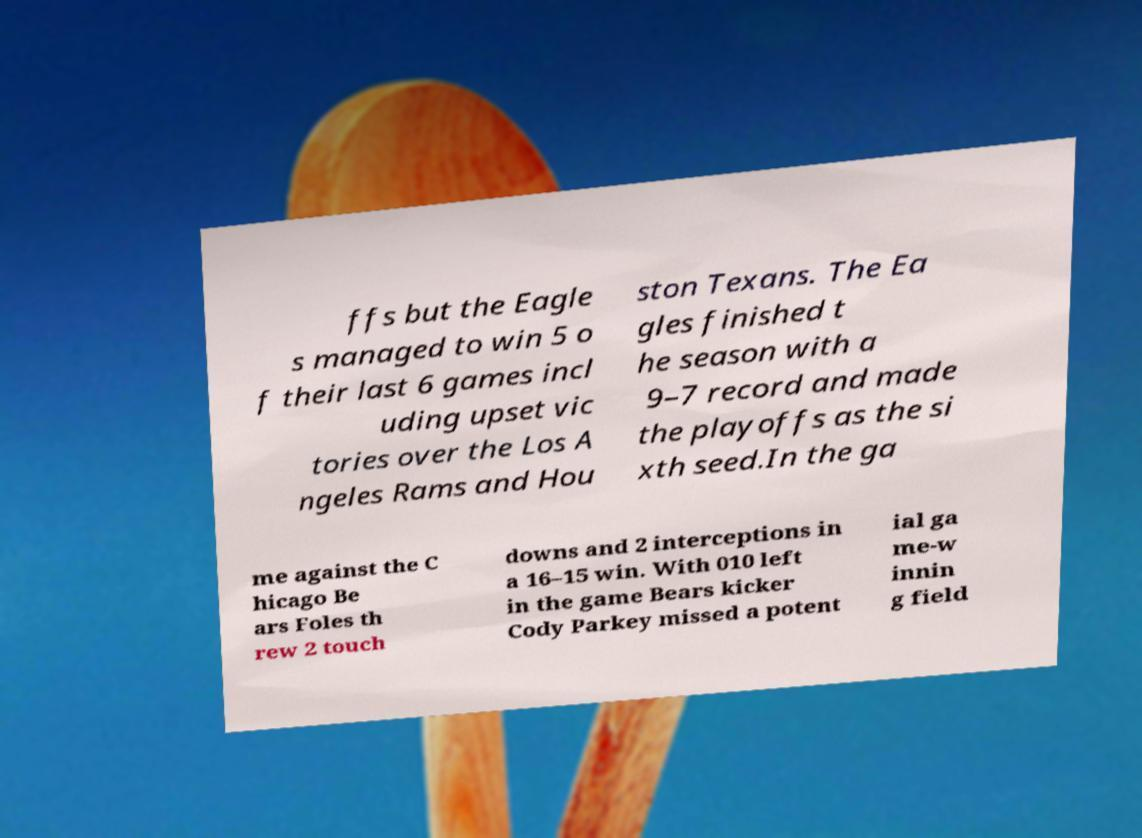Please read and relay the text visible in this image. What does it say? ffs but the Eagle s managed to win 5 o f their last 6 games incl uding upset vic tories over the Los A ngeles Rams and Hou ston Texans. The Ea gles finished t he season with a 9–7 record and made the playoffs as the si xth seed.In the ga me against the C hicago Be ars Foles th rew 2 touch downs and 2 interceptions in a 16–15 win. With 010 left in the game Bears kicker Cody Parkey missed a potent ial ga me-w innin g field 